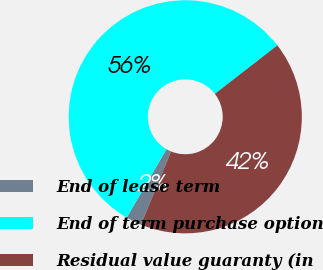<chart> <loc_0><loc_0><loc_500><loc_500><pie_chart><fcel>End of lease term<fcel>End of term purchase option<fcel>Residual value guaranty (in<nl><fcel>2.17%<fcel>56.12%<fcel>41.71%<nl></chart> 